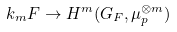Convert formula to latex. <formula><loc_0><loc_0><loc_500><loc_500>k _ { m } F \to H ^ { m } ( G _ { F } , \mu _ { p } ^ { \otimes m } )</formula> 